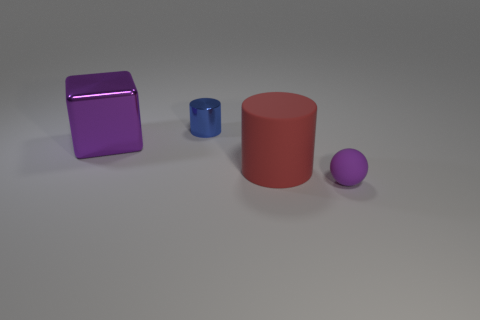What number of things are large red rubber things or large yellow matte objects?
Your response must be concise. 1. How big is the thing on the right side of the big red matte thing?
Offer a very short reply. Small. What number of other things are there of the same material as the large cube
Provide a short and direct response. 1. There is a cylinder in front of the blue metal cylinder; are there any large purple shiny blocks in front of it?
Offer a very short reply. No. Are there any other things that are the same shape as the tiny blue metal object?
Provide a succinct answer. Yes. What color is the shiny object that is the same shape as the red rubber object?
Your answer should be compact. Blue. What size is the red rubber thing?
Your answer should be compact. Large. Is the number of shiny blocks on the right side of the large cube less than the number of shiny objects?
Make the answer very short. Yes. Does the small purple thing have the same material as the large thing that is to the left of the blue cylinder?
Your answer should be compact. No. There is a rubber thing on the left side of the rubber thing in front of the big matte cylinder; is there a tiny blue cylinder on the left side of it?
Your answer should be very brief. Yes. 